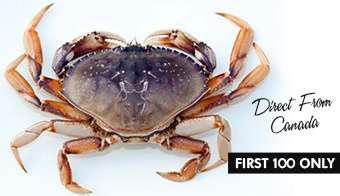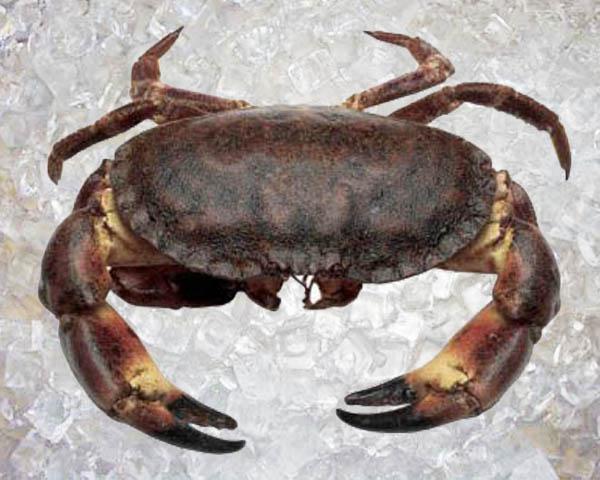The first image is the image on the left, the second image is the image on the right. Considering the images on both sides, is "The left image contains one forward-facing crab with its front claws somewhat extended and its top shell visible." valid? Answer yes or no. No. 